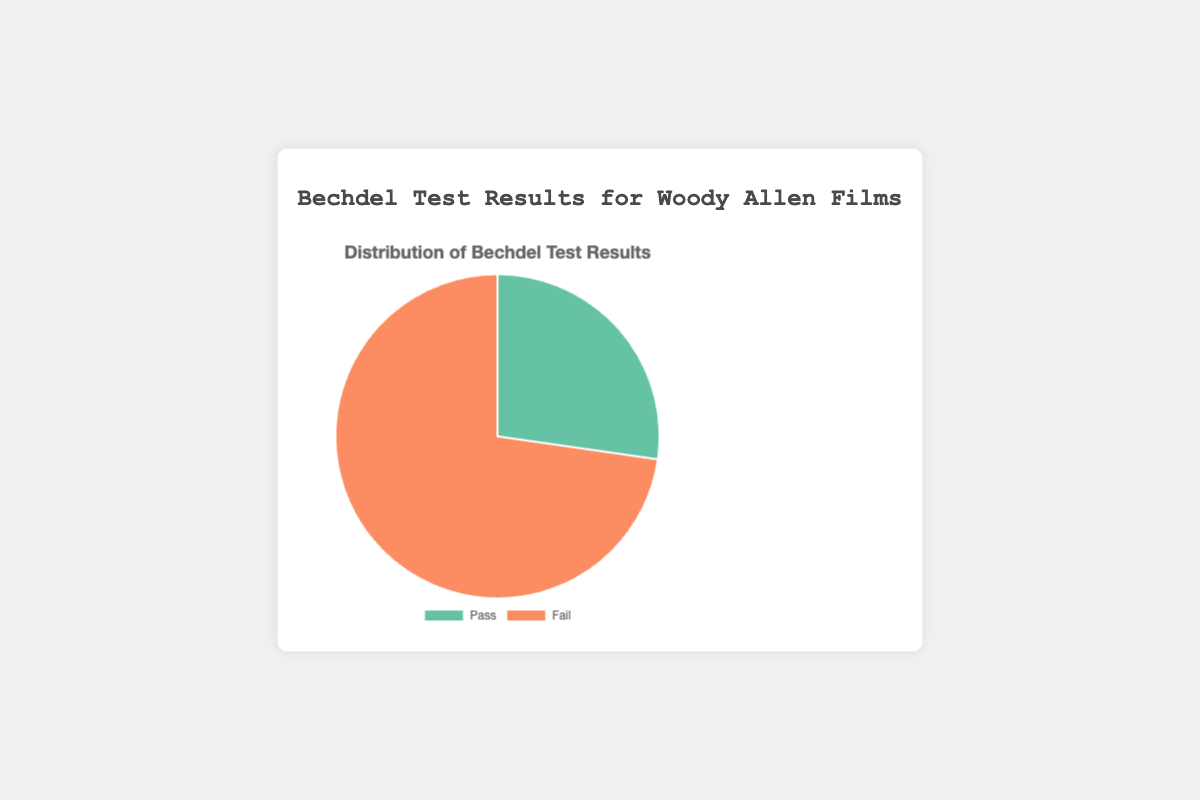Which Bechdel Test result category has the higher count? By looking at the pie chart, we can see which section is larger. The "Fail" section is significantly larger than the "Pass" section.
Answer: Fail What percentage of Woody Allen's films pass the Bechdel Test? We need to identify the "Pass" section of the pie chart and look at the tooltip or labels. According to the chart, "Pass" constitutes 27.3% of the films.
Answer: 27.3% What is the ratio of films that fail the Bechdel Test to those that pass? Look at the counts in each category from the chart. There are 8 films that fail and 3 films that pass, giving us a ratio of 8:3.
Answer: 8:3 How many more films fail the Bechdel Test than pass it? Count the number of films in each section. There are 8 films that fail and 3 films that pass. Subtracting the two gives 8 - 3 = 5.
Answer: 5 If we were to add another film that passes the Bechdel Test, what would the new percentage of passing films be? There are currently 3 passing films out of 11 total films. Adding one more passing film changes it to 4 passing films out of 12 total films. The new percentage is (4/12)*100 = 33.3%.
Answer: 33.3% How does the number of failing films compare to the sum of passing and failing films? There are 8 failing films. The sum of passing (3) and failing (8) films is 11. We compare 8 to 11, which indicates that failing films constitute a majority.
Answer: Major Which color represents the films that pass the Bechdel Test? By observing the pie chart’s legend, the "Pass" category is shown in green.
Answer: Green What is the total number of Woody Allen films represented in the pie chart? We need to sum up both "Pass" and "Fail" sections. There are 3 films that pass and 8 that fail, which totals 11 films.
Answer: 11 What fraction of the total films does the ‘Fail’ category represent? There are 8 failing films out of 11 total films. The fraction is 8/11.
Answer: 8/11 How would the representation in the pie chart change if two additional films that fail the Bechdel Test were added? If 2 more failing films are added, the counts would be 3 Pass and 10 Fail. The new percentages would be (3/13)*100 ≈ 23.1% Pass and (10/13)*100 ≈ 76.9% Fail. This would make the "Fail" section even larger visually.
Answer: 23.1% Pass, 76.9% Fail 